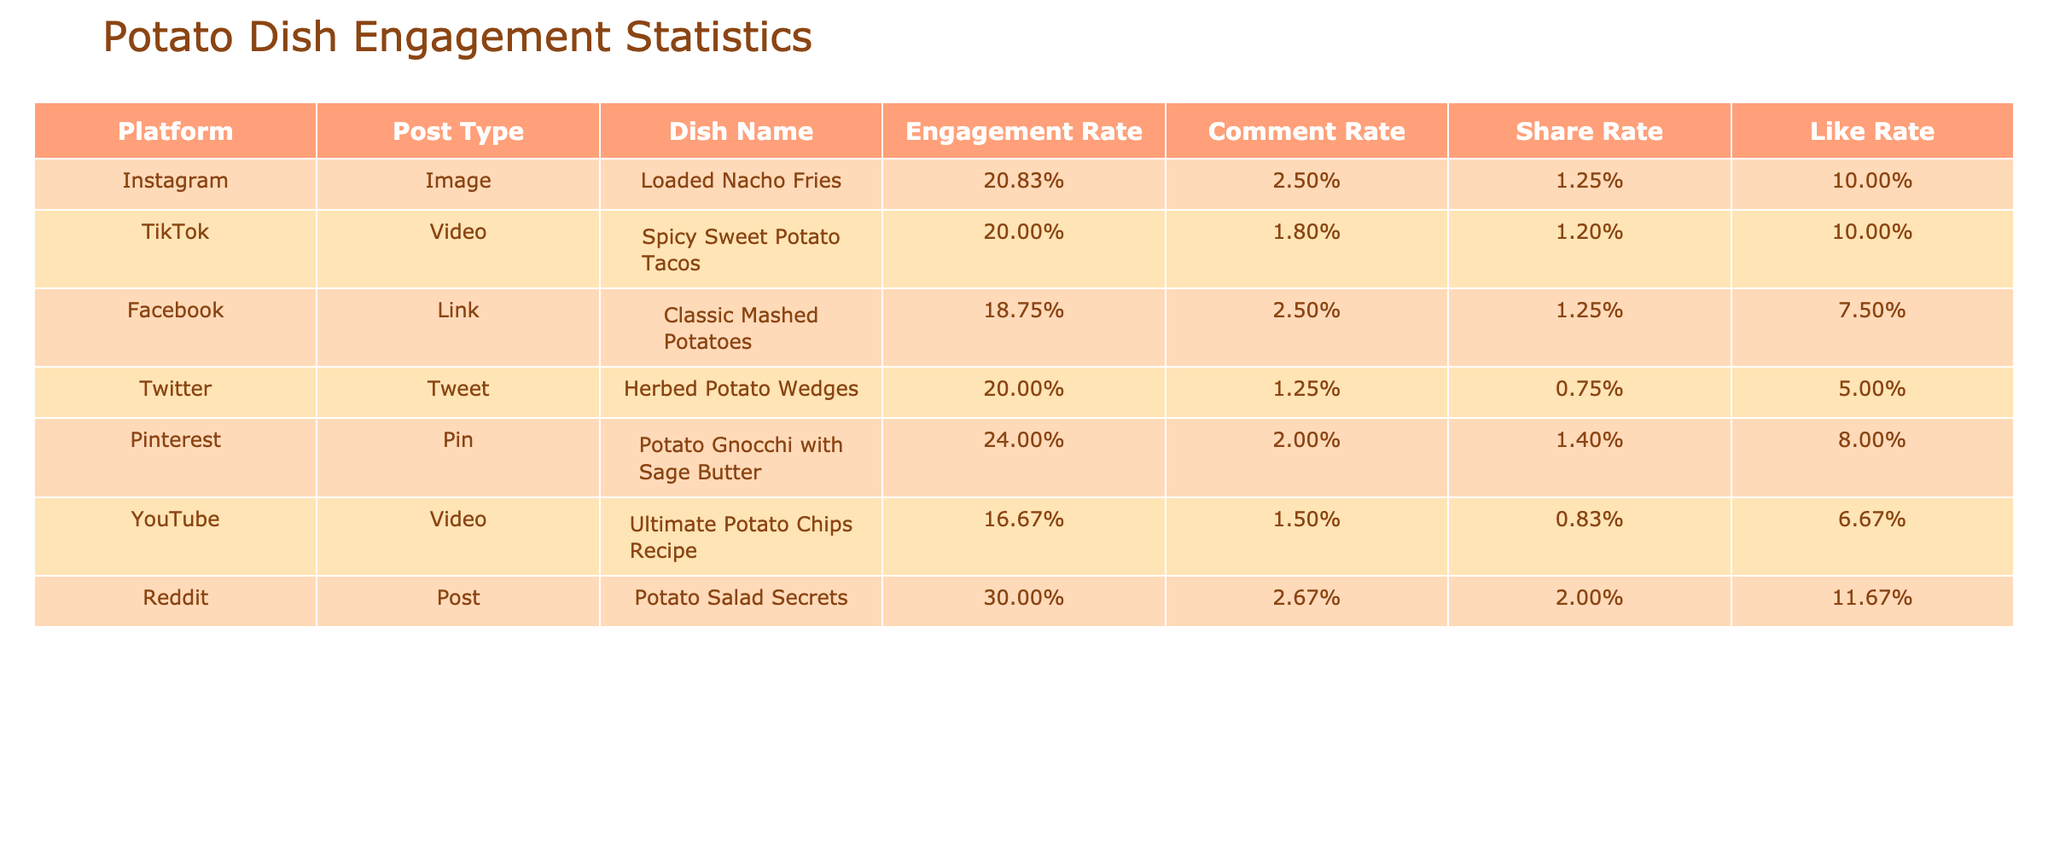What is the engagement rate for the video post type on YouTube? The engagement rate for the video post type on YouTube can be calculated by taking the engagements (10,000) and dividing it by the views (60,000), which gives us 10,000 / 60,000 = 0.1667, or approximately 16.67% when expressed as a percentage.
Answer: 16.67% Which potato dish received the highest number of likes? By looking at the likes column, the dish "Ultimate Potato Chips Recipe" on YouTube has 4,000 likes, which is the highest among all the dishes listed in the table.
Answer: Ultimate Potato Chips Recipe Did any of the posts receive more than 2,000 engagements? To determine this, we can review the engagements column and identify that both "Spicy Sweet Potato Tacos" and "Ultimate Potato Chips Recipe" have engagements of 5,000 and 10,000 respectively, which are both greater than 2,000.
Answer: Yes What is the average number of views for potato dishes across all platforms? To find the average views, we sum all views: 12,000 + 25,000 + 8,000 + 4,000 + 5,000 + 60,000 + 3,000 = 117,000. There are 7 posts, so we calculate the average as 117,000 / 7 ≈ 16,714.29.
Answer: 16,714.29 Does the platform TikTok have a higher share rate than Twitter? First, we check the share rates: for TikTok, shares are 300 and views are 25,000, resulting in a share rate of 300 / 25,000 = 0.012 or 1.2%. For Twitter, shares are 30 and views are 4,000, giving a share rate of 30 / 4,000 = 0.0075 or 0.75%. Since 1.2% is greater than 0.75%, TikTok has a higher share rate than Twitter.
Answer: Yes What is the difference in total engagements between the "Loaded Nacho Fries" and "Potato Gnocchi with Sage Butter"? The total engagements for "Loaded Nacho Fries" is 2,500 and for "Potato Gnocchi with Sage Butter" it is 1,200. The difference is 2,500 - 1,200 = 1,300.
Answer: 1,300 Which post type has the lowest engagement rate on average? To find the post type with the lowest engagement rate, we calculate the engagement rates for each post: Image, 20.83%; Video, 20.00%; Link, 18.75%; Tweet, 20.00%; Pin, 24.00%; and Post, 30.00%. The Link post type has the lowest average engagement rate at 18.75%.
Answer: Link Is the dish "Classic Mashed Potatoes" performing better in terms of comments or shares? The comments for "Classic Mashed Potatoes" are 200, and the shares are 100. Since 200 is greater than 100, it shows that this dish is performing better in terms of comments.
Answer: Comments 